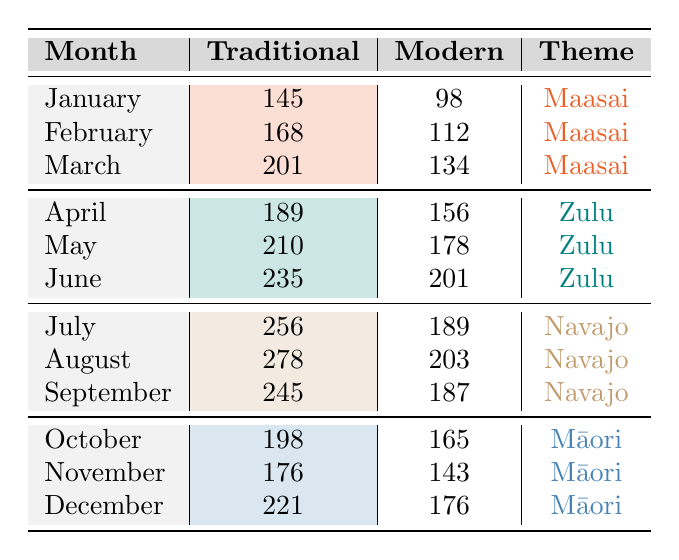What is the total number of traditional room bookings in June 2023? The table shows that in June 2023, there were 235 traditional room bookings.
Answer: 235 What is the difference in the number of modern room bookings between July and August 2023? In July 2023, there were 189 modern room bookings, and in August 2023, there were 203. The difference is 203 - 189 = 14.
Answer: 14 Which month had the highest booking for traditional rooms in the Zulu theme? Looking at the Zulu theme months (April, May, June), June has the highest booking at 235 traditional rooms.
Answer: June What is the average number of modern room bookings for the Maasai theme? The modern room bookings for the Maasai theme (January: 98, February: 112, March: 134) are summed up to 98 + 112 + 134 = 344. There are 3 months, so the average = 344 / 3 = 114.67, which rounds to 115.
Answer: 115 Did the traditional room bookings increase from February to March 2023? Traditional room bookings were 168 in February and increased to 201 in March, confirming an increase.
Answer: Yes What was the total number of traditional room bookings in 2023? Adding all the traditional room bookings for each month: 145 (Jan) + 168 (Feb) + 201 (Mar) + 189 (Apr) + 210 (May) + 235 (Jun) + 256 (Jul) + 278 (Aug) + 245 (Sep) + 198 (Oct) + 176 (Nov) + 221 (Dec) gives a total of 2,195.
Answer: 2195 What is the proportion of modern room bookings in September compared to traditional room bookings for the Navajo theme? In September 2023, there were 187 modern room bookings and 245 traditional room bookings. The proportion is 187 / 245 = 0.76, or 76%.
Answer: 76% In which months is the traditional room booking higher than modern room bookings for the Māori theme? For the Māori theme, traditional room bookings were higher than modern in October (198 vs 165), November (176 vs 143), and December (221 vs 176).
Answer: October, November, December What is the total number of bookings (both traditional and modern) in May 2023? May had 210 traditional and 178 modern room bookings. The total is 210 + 178 = 388.
Answer: 388 Which month had the least demand for modern rooms in the Zulu theme? The modern room bookings for the Zulu theme are: April (156), May (178), June (201). The least demand is in April with 156 modern room bookings.
Answer: April 